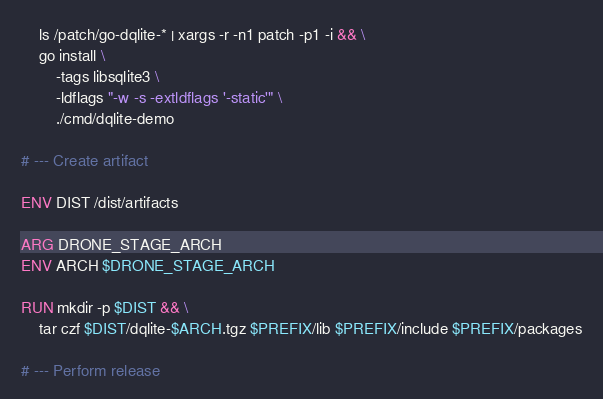<code> <loc_0><loc_0><loc_500><loc_500><_Dockerfile_>    ls /patch/go-dqlite-* | xargs -r -n1 patch -p1 -i && \
    go install \
        -tags libsqlite3 \
        -ldflags "-w -s -extldflags '-static'" \
        ./cmd/dqlite-demo

# --- Create artifact

ENV DIST /dist/artifacts

ARG DRONE_STAGE_ARCH
ENV ARCH $DRONE_STAGE_ARCH

RUN mkdir -p $DIST && \
    tar czf $DIST/dqlite-$ARCH.tgz $PREFIX/lib $PREFIX/include $PREFIX/packages

# --- Perform release
</code> 